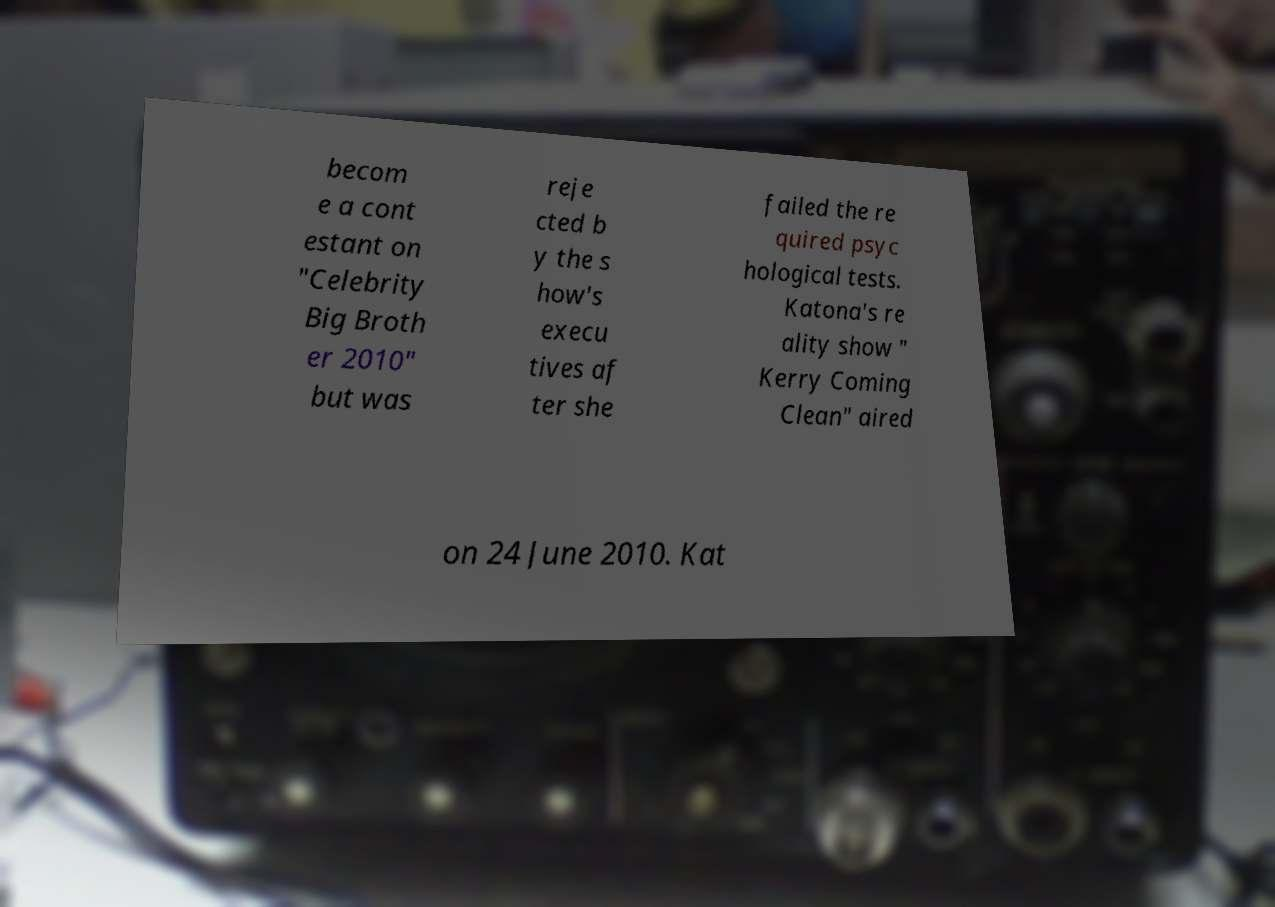What messages or text are displayed in this image? I need them in a readable, typed format. becom e a cont estant on "Celebrity Big Broth er 2010" but was reje cted b y the s how's execu tives af ter she failed the re quired psyc hological tests. Katona's re ality show " Kerry Coming Clean" aired on 24 June 2010. Kat 